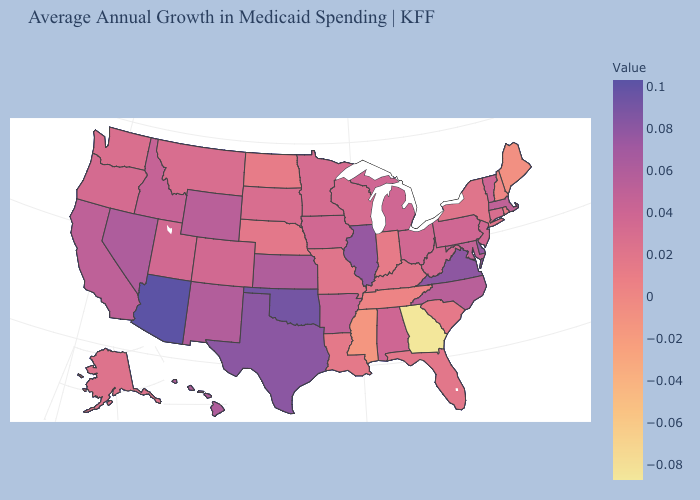Does the map have missing data?
Quick response, please. No. Does the map have missing data?
Short answer required. No. Does Georgia have the lowest value in the USA?
Give a very brief answer. Yes. Does Rhode Island have a lower value than Mississippi?
Give a very brief answer. No. 